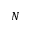Convert formula to latex. <formula><loc_0><loc_0><loc_500><loc_500>N</formula> 